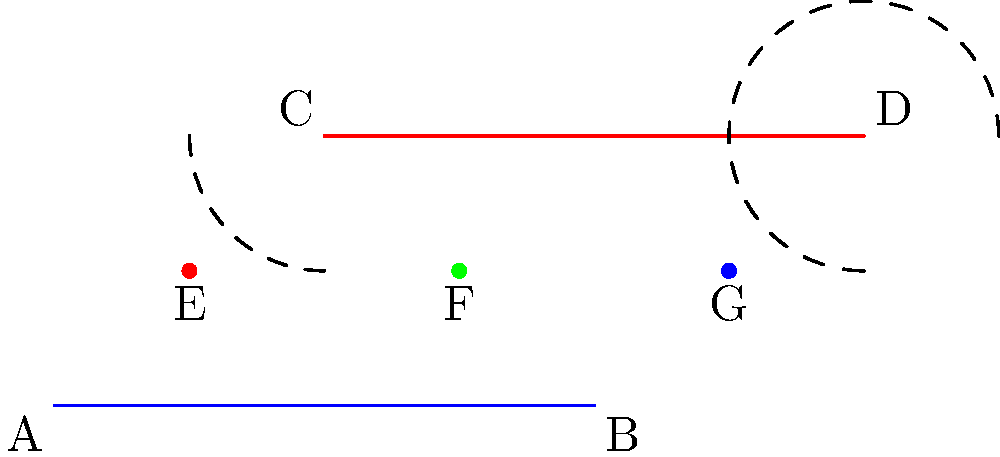In a hyperbolic market model, two parallel lines represent competing product lines. Points E, F, and G represent different suppliers positioned along these lines. If the distance between the parallel lines decreases as we move from left to right (following the curvature of hyperbolic space), which supplier is best positioned to serve both product lines efficiently? To solve this problem, we need to consider the properties of parallel lines in hyperbolic geometry and how they relate to our market model:

1. In hyperbolic geometry, parallel lines diverge from each other as they extend in one direction and converge in the other.

2. In our model, the blue line (AB) and red line (CD) represent parallel product lines in a hyperbolic market space.

3. The decreasing distance between the lines from left to right indicates that the market space is converging in that direction.

4. Suppliers E, F, and G are positioned at different points along this converging space.

5. The supplier closest to the point of convergence will be best positioned to serve both product lines efficiently, as they will have the shortest distance to both lines.

6. Examining the positions:
   - E is furthest from the convergence point
   - F is in the middle
   - G is closest to the convergence point

7. Therefore, supplier G is in the best position to efficiently serve both product lines, as it requires the least "distance" in the hyperbolic market space to reach both lines.

This model can be used to understand how different suppliers or competitors are positioned in a market where product lines or market segments converge, allowing for strategic decision-making in supplier selection or market positioning.
Answer: Supplier G 